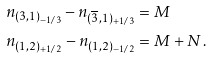Convert formula to latex. <formula><loc_0><loc_0><loc_500><loc_500>n _ { ( 3 , 1 ) _ { - 1 / 3 } } - n _ { ( \overline { 3 } , 1 ) _ { + 1 / 3 } } & = M \\ n _ { ( 1 , 2 ) _ { + 1 / 2 } } - n _ { ( 1 , 2 ) _ { - 1 / 2 } } & = M + N \, .</formula> 